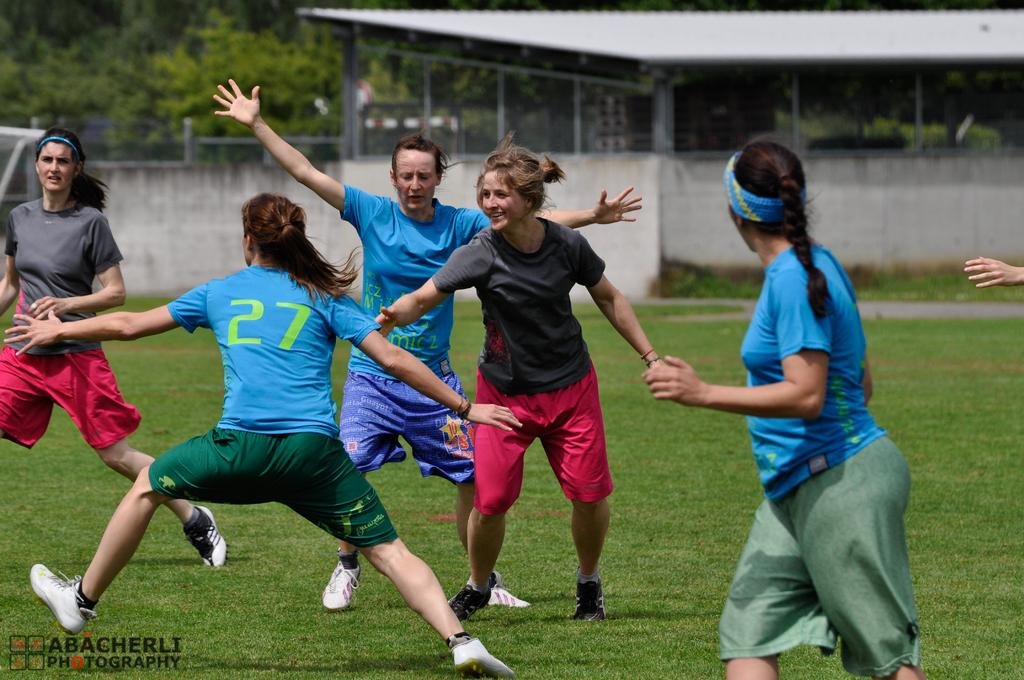What is the main subject of the image? The main subject of the image is a group of women. What are the women doing in the image? Some women are running on the ground, some are running on a wall, and some are running on grass. Can you describe the shelter in the image? There is a shelter in the image, but its specific features are not mentioned in the facts. What can be seen in the background of the image? There are trees in the background of the image. What type of quince can be seen on the chessboard in the image? There is no chessboard or quince present in the image. What color is the suit worn by the woman running on the wall? The facts do not mention any specific clothing worn by the women in the image. 